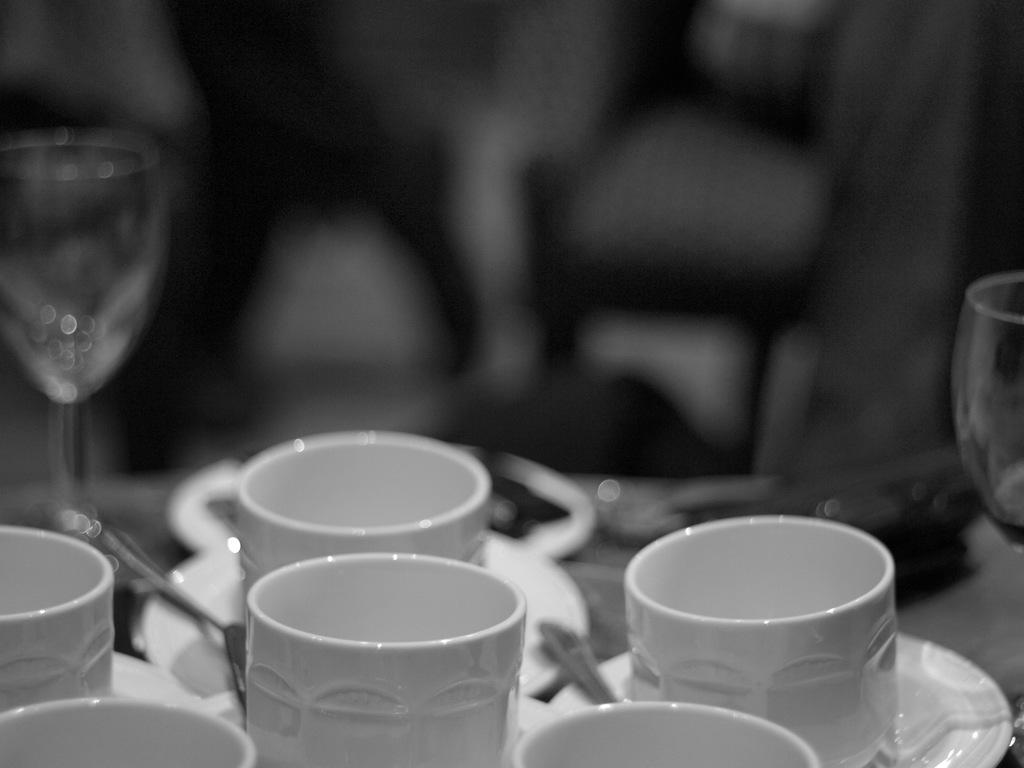What type of picture is in the image? The image contains a black and white picture. What color are the cups in the picture? The cups in the picture are white colored. What type of glassware is in the picture? There are wine glasses in the picture. What utensils are in the picture? There are spoons in the picture. What type of dishware is in the picture? There are plates in the picture. How would you describe the background of the picture? The background of the picture is blurry. What type of square is present in the image? There is no square present in the image. Can you tell me who made the request for more wine glasses in the image? There is no indication of a request for more wine glasses in the image. 